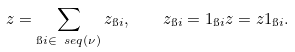Convert formula to latex. <formula><loc_0><loc_0><loc_500><loc_500>z = \sum _ { \i i \in \ s e q ( \nu ) } z _ { \i i } , \quad z _ { \i i } = 1 _ { \i i } z = z 1 _ { \i i } .</formula> 